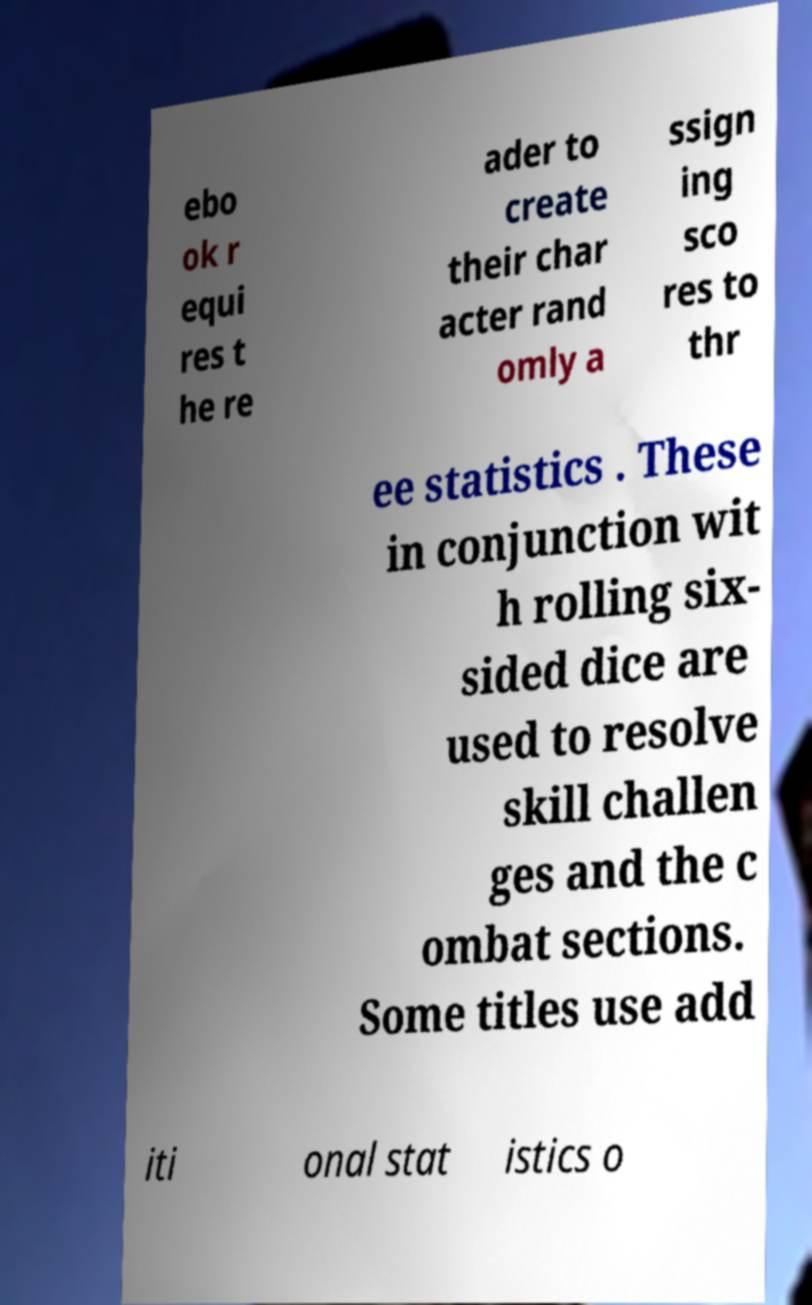For documentation purposes, I need the text within this image transcribed. Could you provide that? ebo ok r equi res t he re ader to create their char acter rand omly a ssign ing sco res to thr ee statistics . These in conjunction wit h rolling six- sided dice are used to resolve skill challen ges and the c ombat sections. Some titles use add iti onal stat istics o 